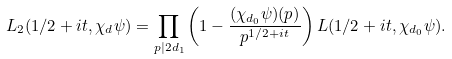<formula> <loc_0><loc_0><loc_500><loc_500>L _ { 2 } ( 1 / 2 + i t , \chi _ { d } \psi ) = \prod _ { p | 2 d _ { 1 } } \left ( 1 - \frac { ( \chi _ { d _ { 0 } } \psi ) ( p ) } { p ^ { 1 / 2 + i t } } \right ) L ( 1 / 2 + i t , \chi _ { d _ { 0 } } \psi ) .</formula> 